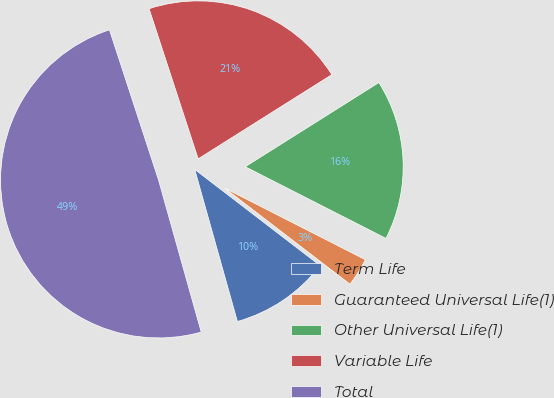<chart> <loc_0><loc_0><loc_500><loc_500><pie_chart><fcel>Term Life<fcel>Guaranteed Universal Life(1)<fcel>Other Universal Life(1)<fcel>Variable Life<fcel>Total<nl><fcel>10.23%<fcel>2.92%<fcel>16.44%<fcel>21.08%<fcel>49.32%<nl></chart> 